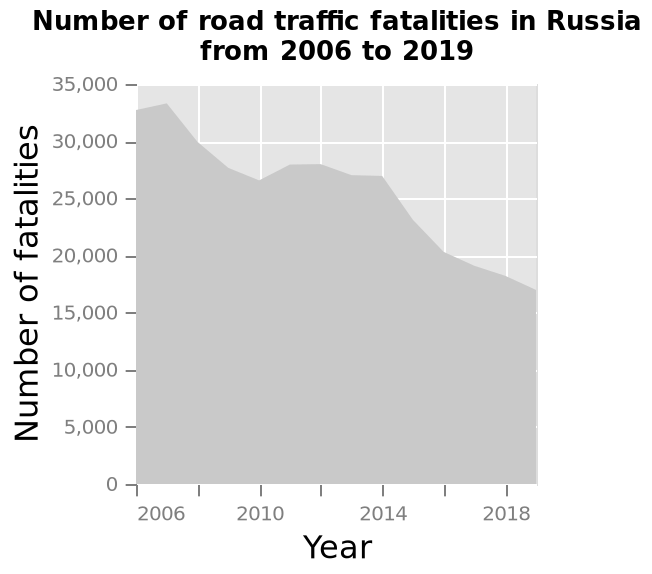<image>
What is the title of the area chart?  The title of the area chart is "Number of road traffic fatalities in Russia from 2006 to 2019." What was the trend in the number of fatalities in Russia between 2006 and 2010? There was a downward trend in the number of fatalities in Russia between 2006 and 2010. Was there an upward trend in the number of fatalities in Russia between 2006 and 2010? No.There was a downward trend in the number of fatalities in Russia between 2006 and 2010. 